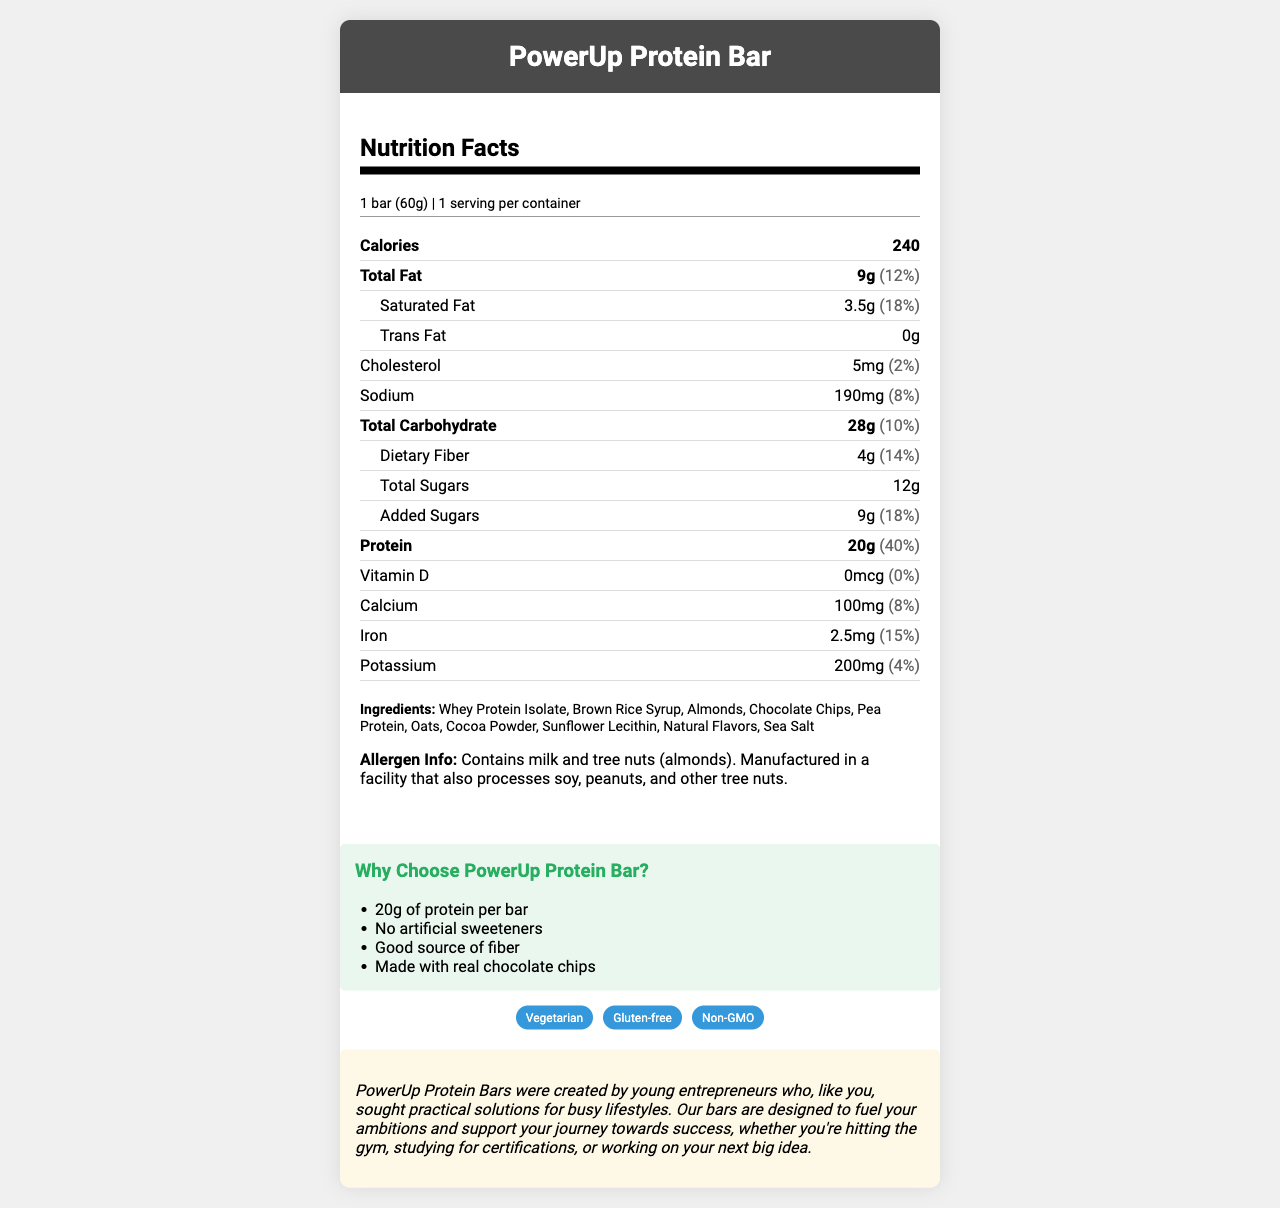what is the calorie content per serving? The document states that each serving of the PowerUp Protein Bar contains 240 calories.
Answer: 240 calories what is the total fat content in the bar? The document lists the total fat content as 9g per serving.
Answer: 9g how much protein does the PowerUp Protein Bar provide? The protein content is specified as 20g per serving in the document.
Answer: 20g what is the daily value percentage of saturated fat in the bar? The document shows that the daily value percentage for saturated fat is 18%.
Answer: 18% what are the two main allergens mentioned in the document? The allergen info section mentions that the product contains milk and tree nuts (almonds).
Answer: Milk and tree nuts (almonds) which ingredient is NOT mentioned in the ingredient list: A. Whey Protein Isolate B. Brown Rice Syrup C. Soy Protein D. Cocoa Powder The document lists Whey Protein Isolate, Brown Rice Syrup, and Cocoa Powder, but does not mention Soy Protein.
Answer: C. Soy Protein where can I buy the PowerUp Protein Bar? A. Convenience stores B. Online marketplaces C. Gym vending machines D. All of the above The document lists convenience stores, gym vending machines, and online marketplaces as retail locations.
Answer: D. All of the above is the PowerUp Protein Bar suitable for vegetarians? The document includes a lifestyle label indicating that the bar is suitable for vegetarians.
Answer: Yes does the PowerUp Protein Bar contain artificial sweeteners? One of the marketing claims states that the bar contains no artificial sweeteners.
Answer: No summarize the main features of the PowerUp Protein Bar The document highlights the nutritional content, ingredients, allergen information, marketing claims, lifestyle labels, and the brand story. The focus is on the nutritious benefits and practical use for active young adults.
Answer: The PowerUp Protein Bar is a high-protein snack designed for young adults with busy lifestyles. Each bar contains 20g of protein, 240 calories, and is made with real ingredients such as Whey Protein Isolate and Chocolate Chips. It is vegetarian, gluten-free, and non-GMO, with no artificial sweeteners. The bar also includes other benefits like being a good source of fiber, and it is available at various retail locations. if I eat two bars, how much sodium will I consume? Each bar contains 190mg of sodium. Consuming two bars will double that amount to 380mg.
Answer: 380mg how many grams of dietary fiber are in a single bar? The document states that there are 4g of dietary fiber per serving.
Answer: 4g what is the brand story of PowerUp Protein Bar? The brand story elaborates on the inspiration behind the bar, focusing on its creation by young entrepreneurs for young adults with active and ambitious lifestyles.
Answer: The PowerUp Protein Bars were created by young entrepreneurs seeking practical solutions for busy lifestyles, designed to fuel ambitions and support various activities like gym workouts, studying, and working on new ideas. how much potassium does one bar provide? The document specifies that one bar contains 200mg of potassium.
Answer: 200mg how much added sugar is in the PowerUp Protein Bar? The document lists 9g of added sugars per serving.
Answer: 9g what is the price of one PowerUp Protein Bar? The document referring to the nutrition facts does not include the price information. Hence, this cannot be determined from the given visual information.
Answer: Cannot be determined 